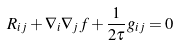<formula> <loc_0><loc_0><loc_500><loc_500>R _ { i j } + \nabla _ { i } \nabla _ { j } f + \frac { 1 } { 2 \tau } g _ { i j } = 0</formula> 